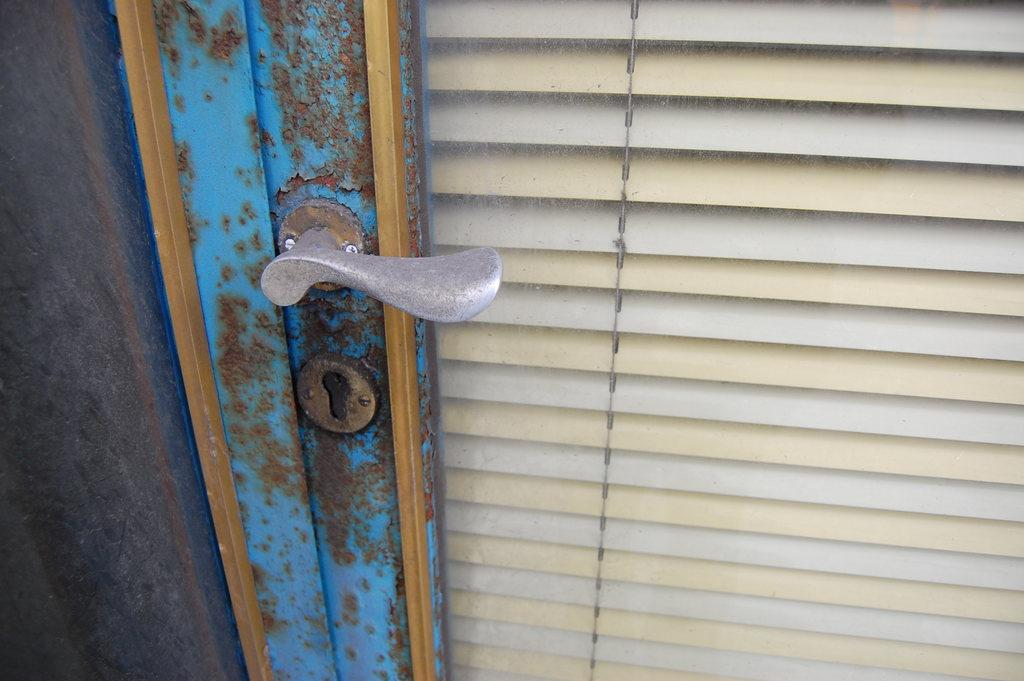What is present in the image that can be used for entering or exiting a room? There is a door in the image that can be used for entering or exiting a room. What feature is present on the door? The door has a handle. What can be used to control the amount of light entering through a window in the image? There are window blinds in the image. What type of plastic material is used to make the door in the image? The door in the image is not made of plastic; it is likely made of wood or another material. How does the presence of the door in the image lead to an increase in communication? The presence of the door in the image does not inherently lead to an increase in communication; it is simply a feature of the room. 